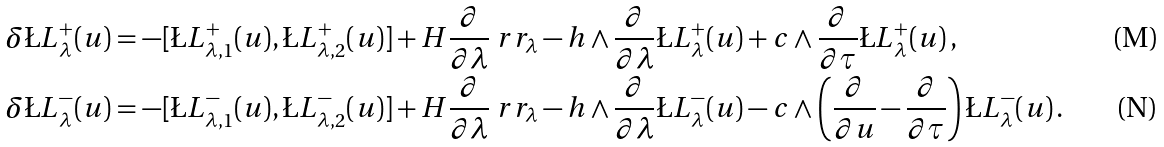<formula> <loc_0><loc_0><loc_500><loc_500>& \delta \L L ^ { + } _ { \lambda } ( u ) = - [ \L L ^ { + } _ { \lambda , 1 } ( u ) , \L L ^ { + } _ { \lambda , 2 } ( u ) ] + H \frac { \partial } { \partial \lambda } \ r r _ { \lambda } - h \wedge \frac { \partial } { \partial \lambda } \L L ^ { + } _ { \lambda } ( u ) + c \wedge \frac { \partial } { \partial \tau } \L L ^ { + } _ { \lambda } ( u ) \, , \\ & \delta \L L ^ { - } _ { \lambda } ( u ) = - [ \L L ^ { - } _ { \lambda , 1 } ( u ) , \L L ^ { - } _ { \lambda , 2 } ( u ) ] + H \frac { \partial } { \partial \lambda } \ r r _ { \lambda } - h \wedge \frac { \partial } { \partial \lambda } \L L ^ { - } _ { \lambda } ( u ) - c \wedge \left ( \frac { \partial } { \partial u } - \frac { \partial } { \partial \tau } \right ) \L L ^ { - } _ { \lambda } ( u ) \, .</formula> 